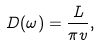Convert formula to latex. <formula><loc_0><loc_0><loc_500><loc_500>D ( \omega ) = \frac { L } { \pi { v } } ,</formula> 